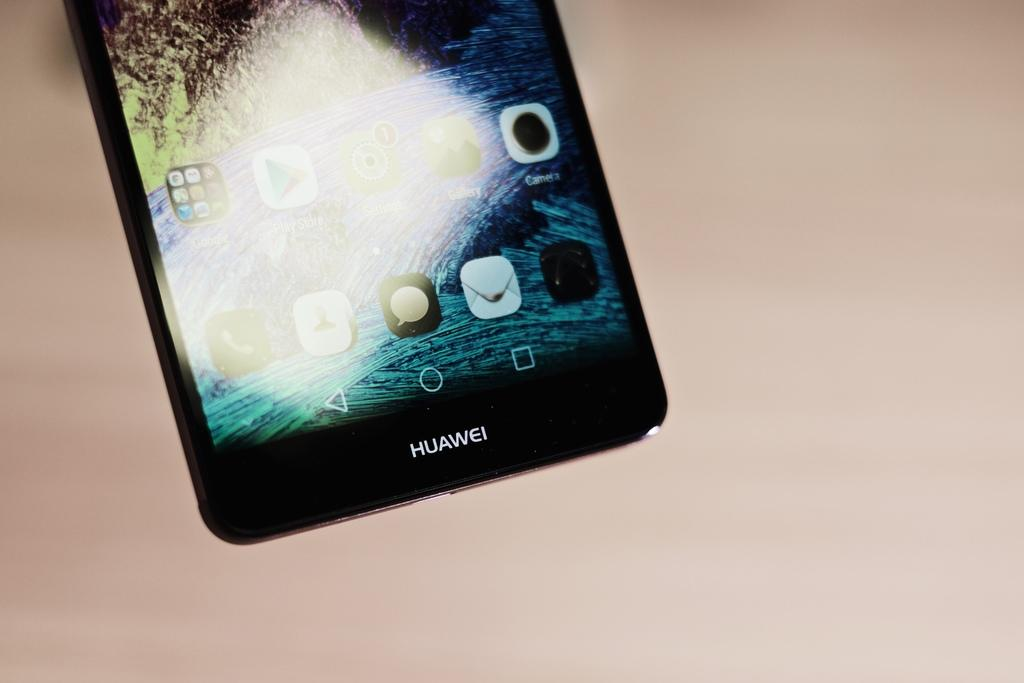<image>
Describe the image concisely. A black Huawei smart phone displays some apps on the screen. 